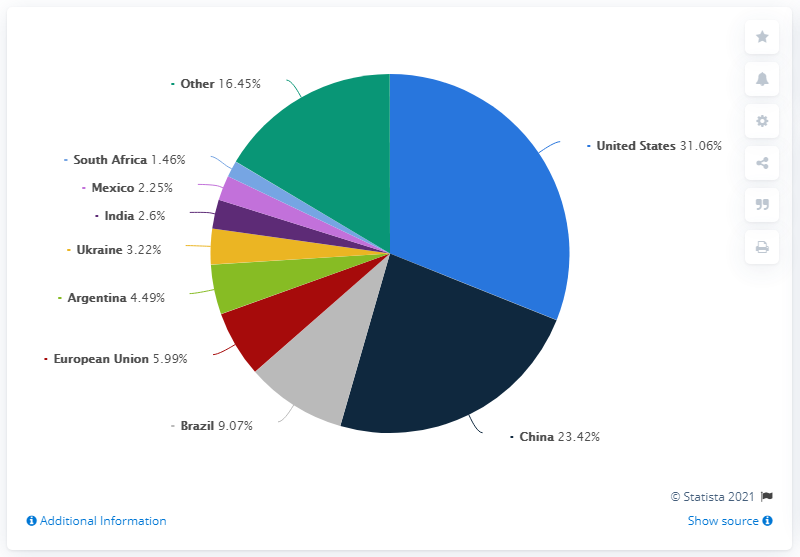Mention a couple of crucial points in this snapshot. The United States is the country with the most distribution of global corn production. The total production of corn in China and Brazil is 32.49 million metric tons. 